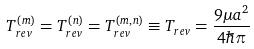<formula> <loc_0><loc_0><loc_500><loc_500>T _ { r e v } ^ { ( m ) } = T _ { r e v } ^ { ( n ) } = T _ { r e v } ^ { ( m , n ) } \equiv T _ { r e v } = \frac { 9 \mu a ^ { 2 } } { 4 \hbar { \pi } }</formula> 